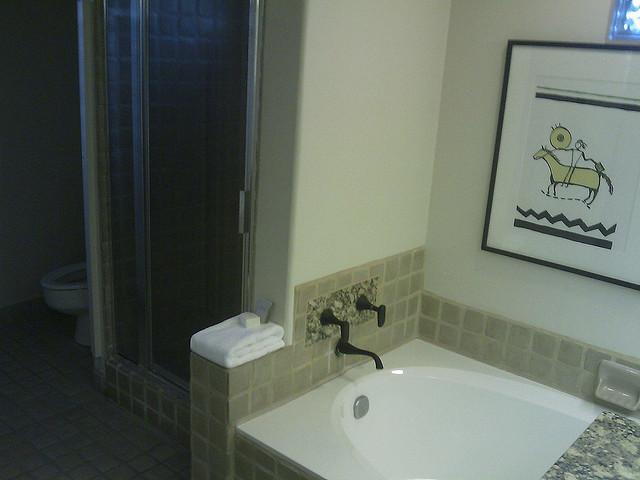How many mirrors are in the picture?
Give a very brief answer. 0. How many picture frames are in this picture?
Give a very brief answer. 1. 